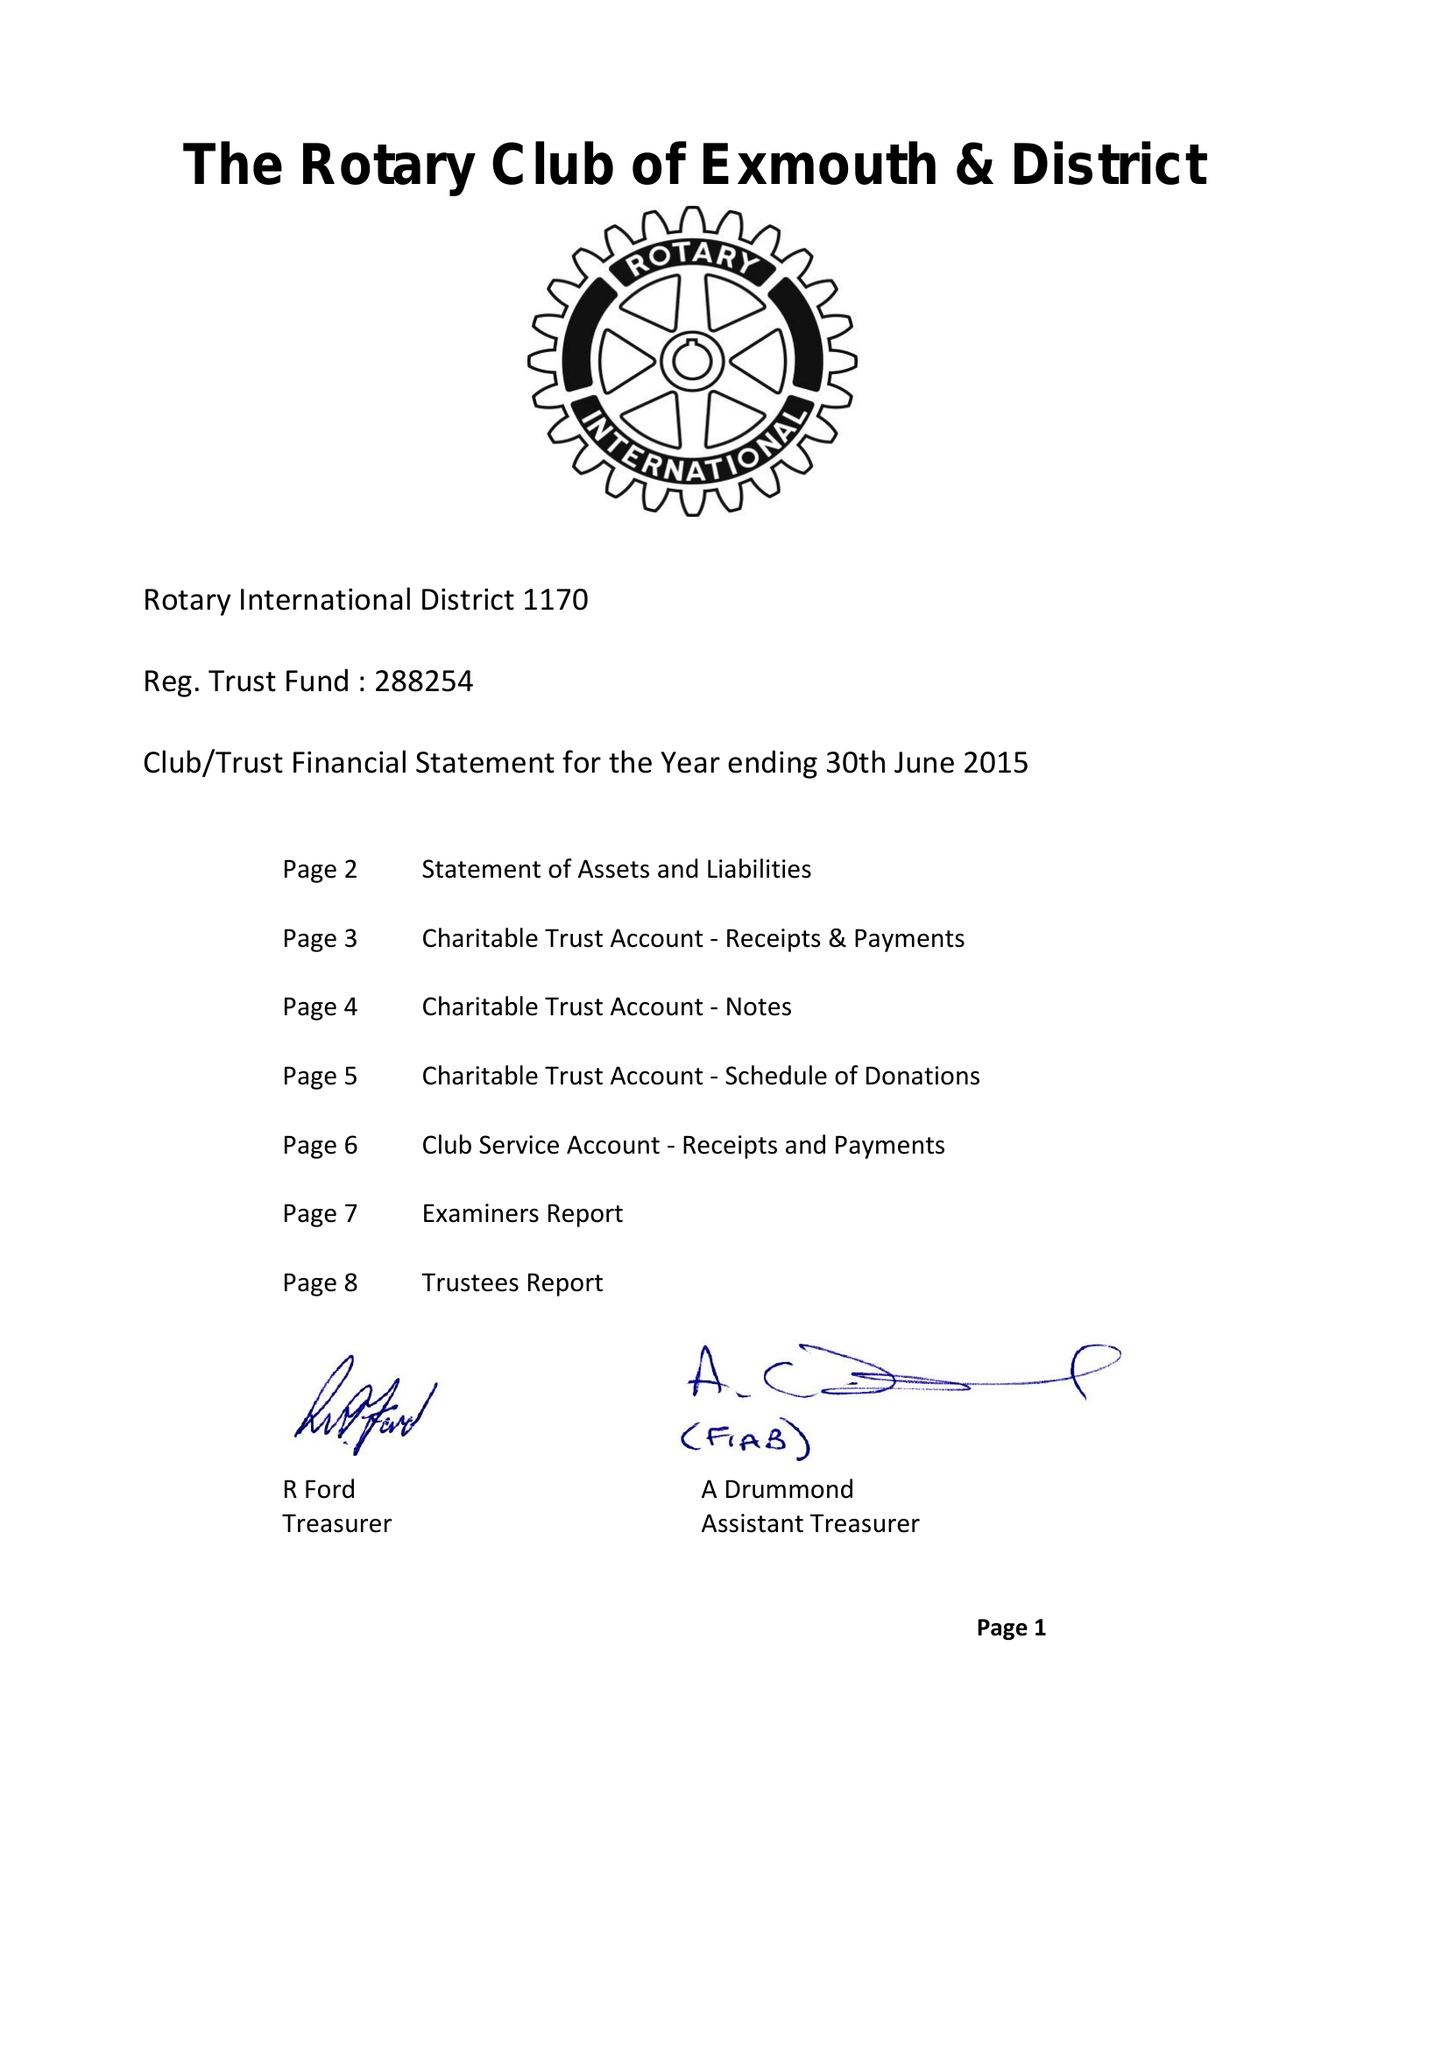What is the value for the address__postcode?
Answer the question using a single word or phrase. EX8 3HP 